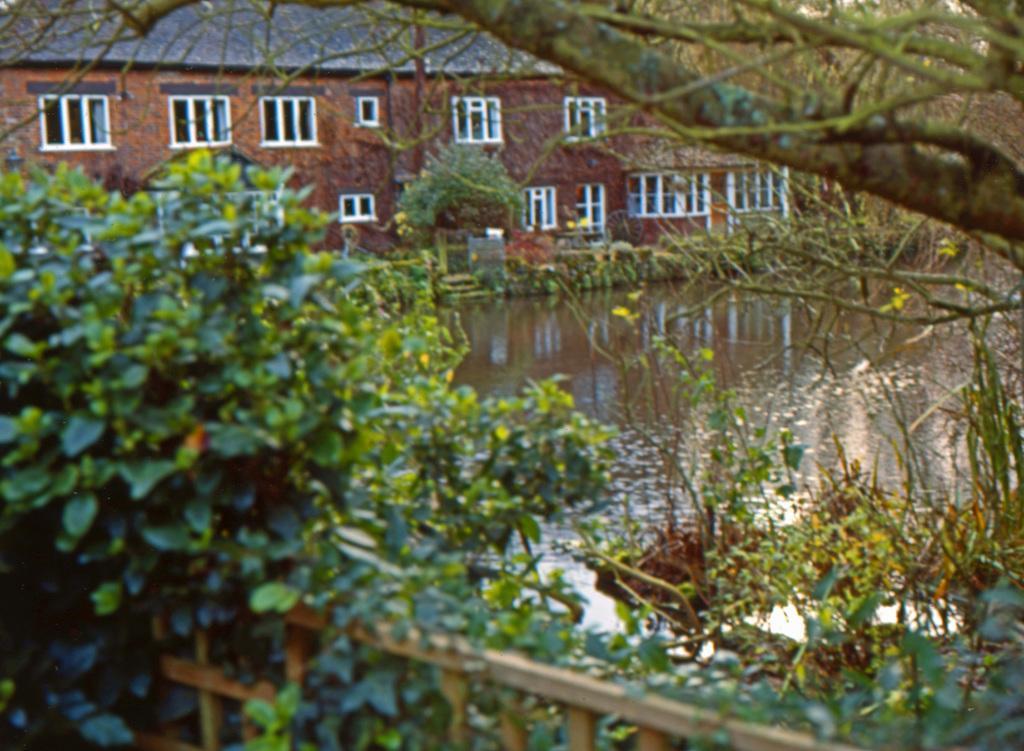Please provide a concise description of this image. We can see tree,plant,grass,fence and water. In the background we can see building,windows and tree. 